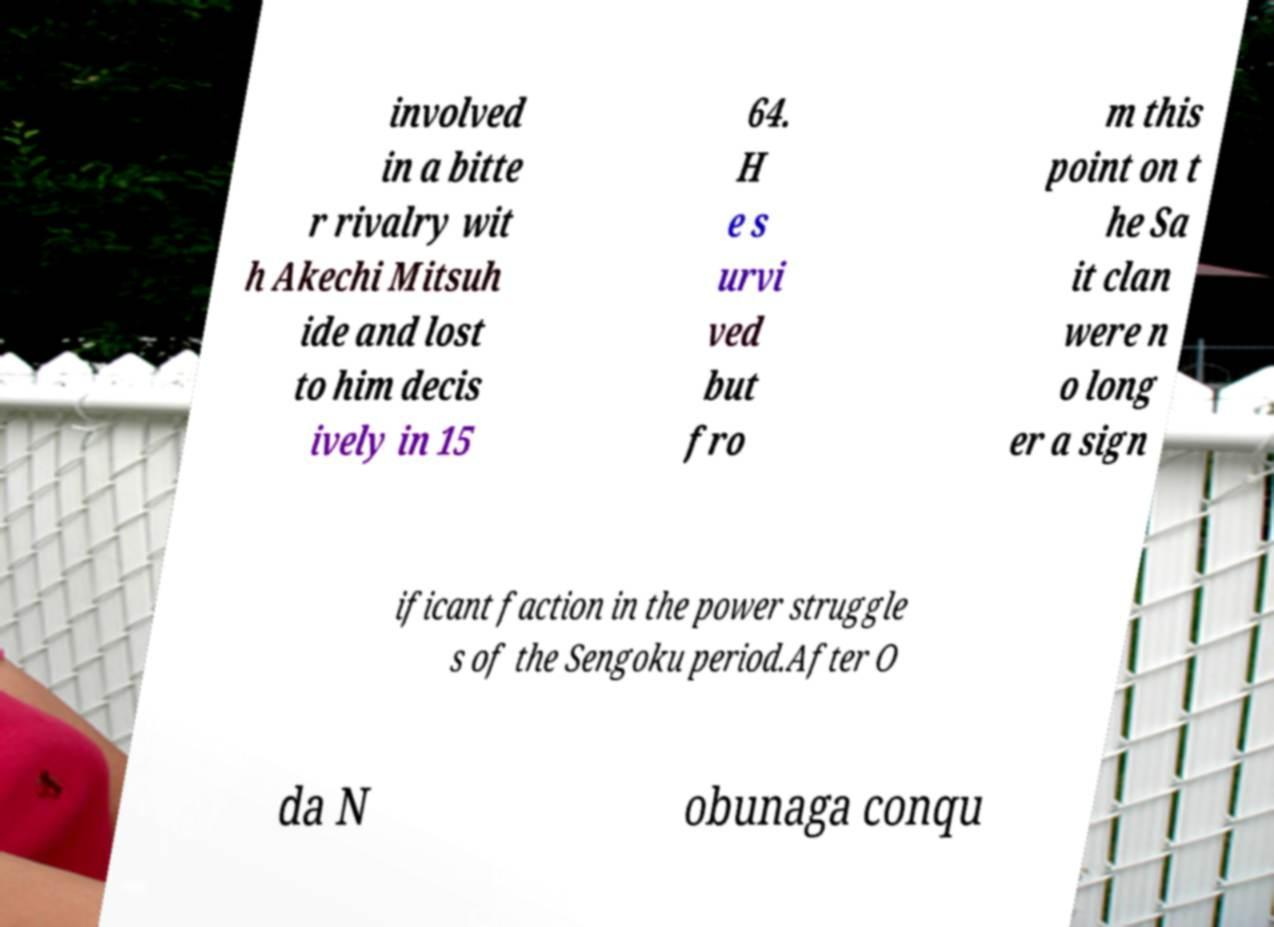For documentation purposes, I need the text within this image transcribed. Could you provide that? involved in a bitte r rivalry wit h Akechi Mitsuh ide and lost to him decis ively in 15 64. H e s urvi ved but fro m this point on t he Sa it clan were n o long er a sign ificant faction in the power struggle s of the Sengoku period.After O da N obunaga conqu 